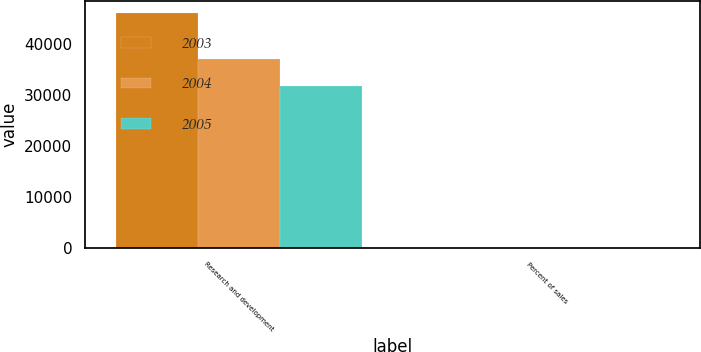Convert chart to OTSL. <chart><loc_0><loc_0><loc_500><loc_500><stacked_bar_chart><ecel><fcel>Research and development<fcel>Percent of sales<nl><fcel>2003<fcel>46000<fcel>6.6<nl><fcel>2004<fcel>37093<fcel>5.6<nl><fcel>2005<fcel>31759<fcel>5.9<nl></chart> 